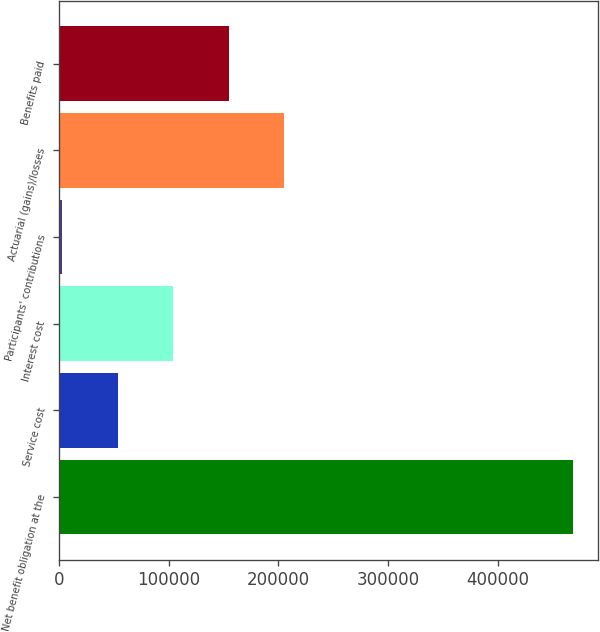Convert chart to OTSL. <chart><loc_0><loc_0><loc_500><loc_500><bar_chart><fcel>Net benefit obligation at the<fcel>Service cost<fcel>Interest cost<fcel>Participants' contributions<fcel>Actuarial (gains)/losses<fcel>Benefits paid<nl><fcel>468439<fcel>53724.4<fcel>104378<fcel>3071<fcel>205685<fcel>155031<nl></chart> 